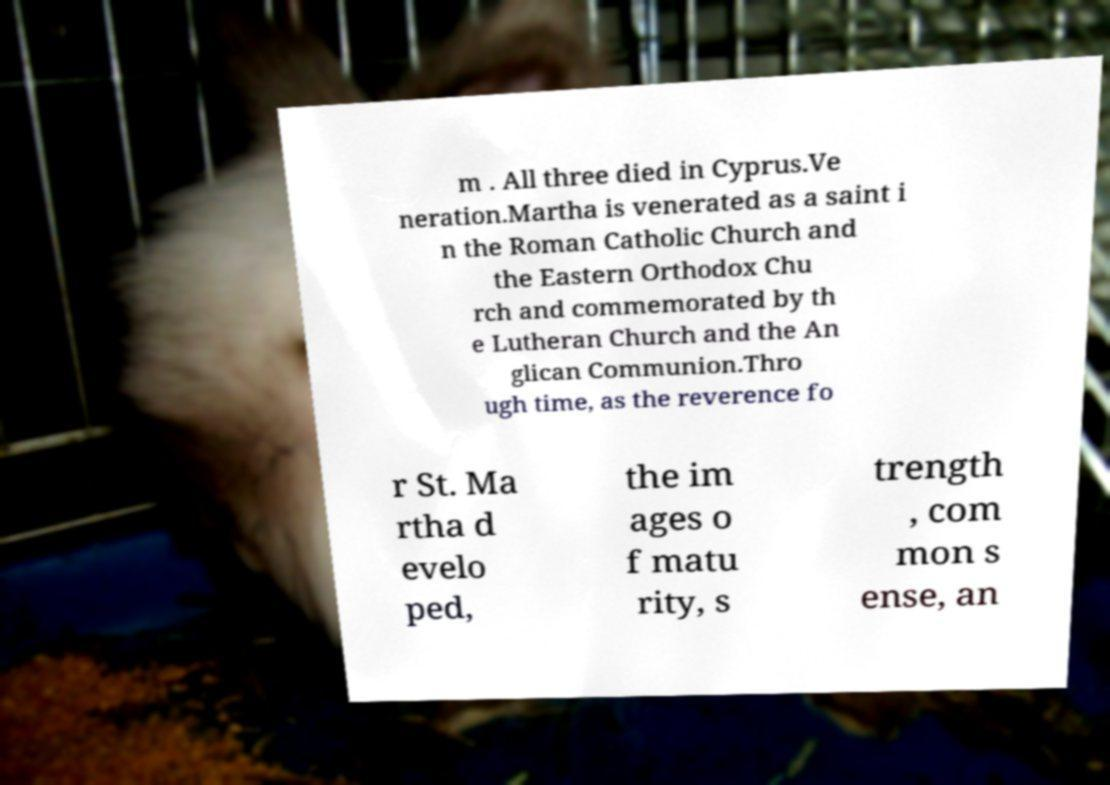For documentation purposes, I need the text within this image transcribed. Could you provide that? m . All three died in Cyprus.Ve neration.Martha is venerated as a saint i n the Roman Catholic Church and the Eastern Orthodox Chu rch and commemorated by th e Lutheran Church and the An glican Communion.Thro ugh time, as the reverence fo r St. Ma rtha d evelo ped, the im ages o f matu rity, s trength , com mon s ense, an 